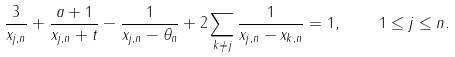<formula> <loc_0><loc_0><loc_500><loc_500>\frac { 3 } { x _ { j , n } } + \frac { a + 1 } { x _ { j , n } + t } - \frac { 1 } { x _ { j , n } - \theta _ { n } } + 2 \sum _ { k \neq j } \frac { 1 } { x _ { j , n } - x _ { k , n } } = 1 , \quad 1 \leq j \leq n .</formula> 